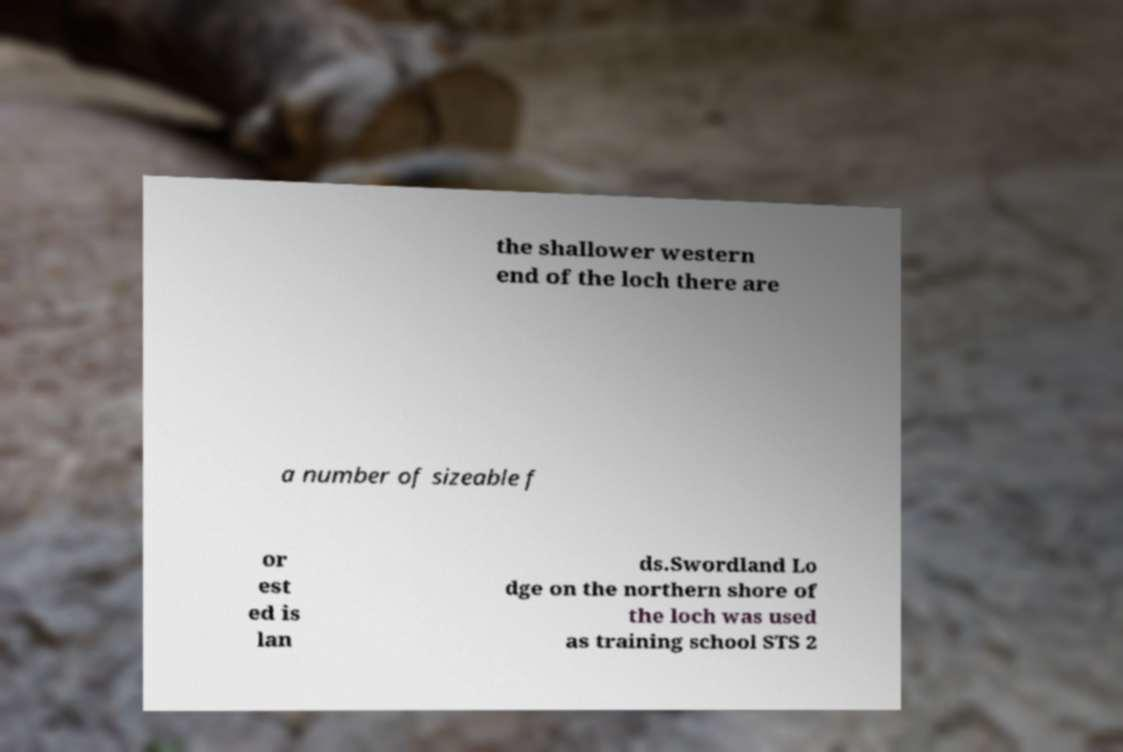Can you read and provide the text displayed in the image?This photo seems to have some interesting text. Can you extract and type it out for me? the shallower western end of the loch there are a number of sizeable f or est ed is lan ds.Swordland Lo dge on the northern shore of the loch was used as training school STS 2 